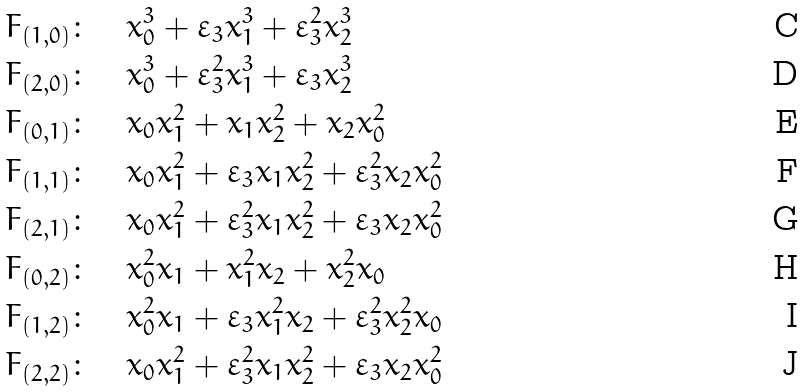<formula> <loc_0><loc_0><loc_500><loc_500>F _ { ( 1 , 0 ) } & \colon \quad x _ { 0 } ^ { 3 } + \varepsilon _ { 3 } x _ { 1 } ^ { 3 } + \varepsilon _ { 3 } ^ { 2 } x _ { 2 } ^ { 3 } \\ F _ { ( 2 , 0 ) } & \colon \quad x _ { 0 } ^ { 3 } + \varepsilon _ { 3 } ^ { 2 } x _ { 1 } ^ { 3 } + \varepsilon _ { 3 } x _ { 2 } ^ { 3 } \\ F _ { ( 0 , 1 ) } & \colon \quad x _ { 0 } x _ { 1 } ^ { 2 } + x _ { 1 } x _ { 2 } ^ { 2 } + x _ { 2 } x _ { 0 } ^ { 2 } \\ F _ { ( 1 , 1 ) } & \colon \quad x _ { 0 } x _ { 1 } ^ { 2 } + \varepsilon _ { 3 } x _ { 1 } x _ { 2 } ^ { 2 } + \varepsilon _ { 3 } ^ { 2 } x _ { 2 } x _ { 0 } ^ { 2 } \\ F _ { ( 2 , 1 ) } & \colon \quad x _ { 0 } x _ { 1 } ^ { 2 } + \varepsilon _ { 3 } ^ { 2 } x _ { 1 } x _ { 2 } ^ { 2 } + \varepsilon _ { 3 } x _ { 2 } x _ { 0 } ^ { 2 } \\ F _ { ( 0 , 2 ) } & \colon \quad x _ { 0 } ^ { 2 } x _ { 1 } + x _ { 1 } ^ { 2 } x _ { 2 } + x _ { 2 } ^ { 2 } x _ { 0 } \\ F _ { ( 1 , 2 ) } & \colon \quad x _ { 0 } ^ { 2 } x _ { 1 } + \varepsilon _ { 3 } x _ { 1 } ^ { 2 } x _ { 2 } + \varepsilon _ { 3 } ^ { 2 } x _ { 2 } ^ { 2 } x _ { 0 } \\ F _ { ( 2 , 2 ) } & \colon \quad x _ { 0 } x _ { 1 } ^ { 2 } + \varepsilon _ { 3 } ^ { 2 } x _ { 1 } x _ { 2 } ^ { 2 } + \varepsilon _ { 3 } x _ { 2 } x _ { 0 } ^ { 2 }</formula> 